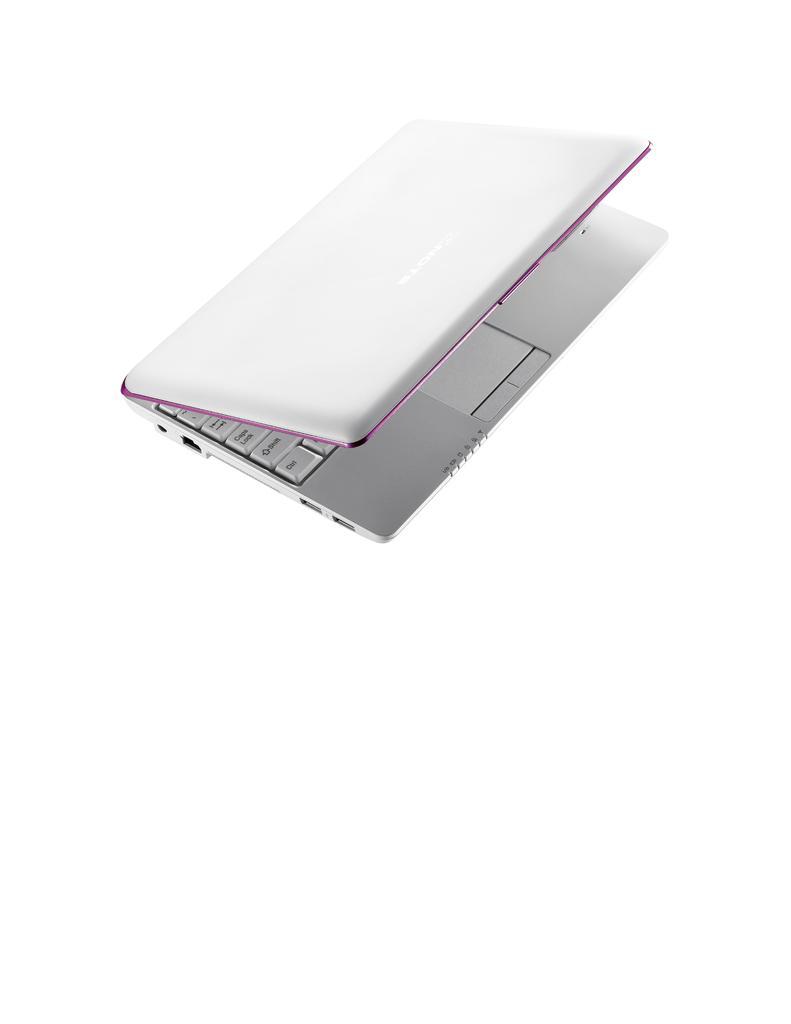Could you give a brief overview of what you see in this image? In this image we can see a laptop. 